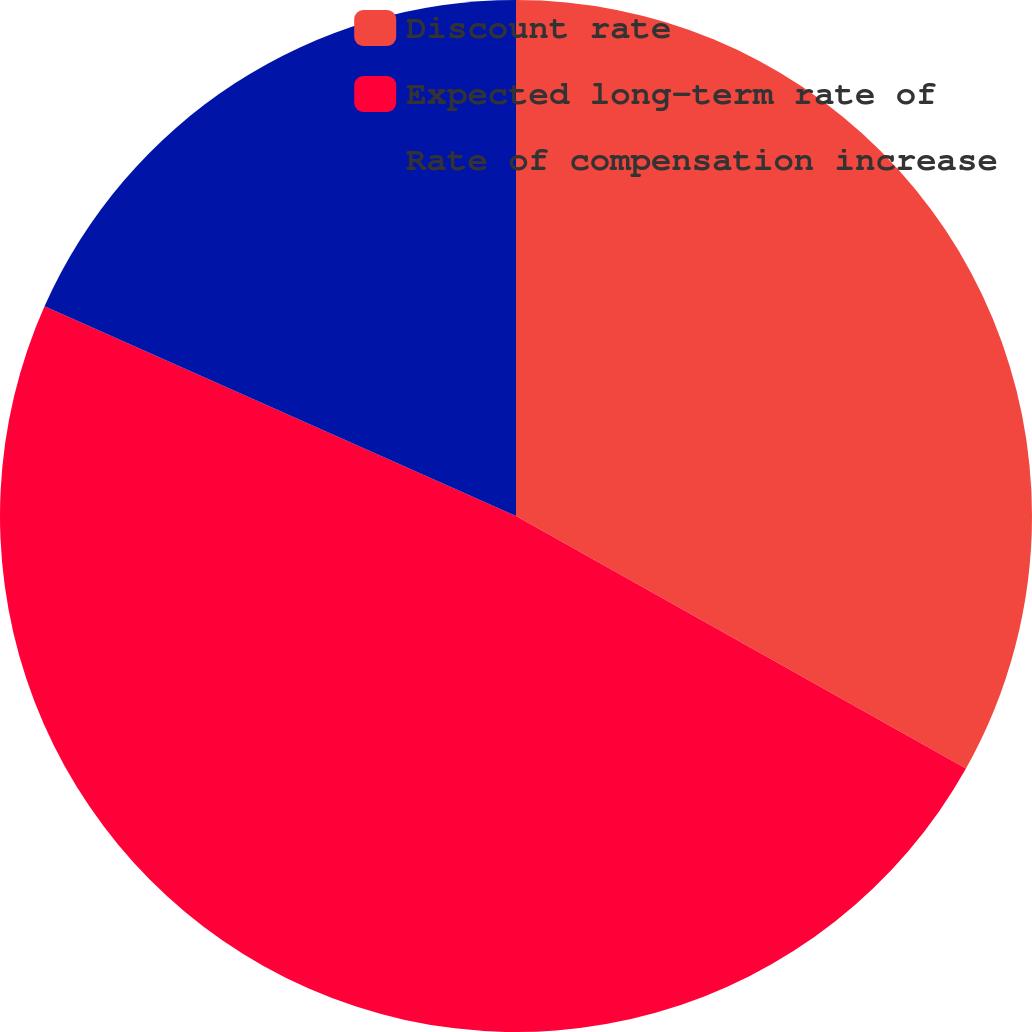Convert chart. <chart><loc_0><loc_0><loc_500><loc_500><pie_chart><fcel>Discount rate<fcel>Expected long-term rate of<fcel>Rate of compensation increase<nl><fcel>33.14%<fcel>48.52%<fcel>18.34%<nl></chart> 